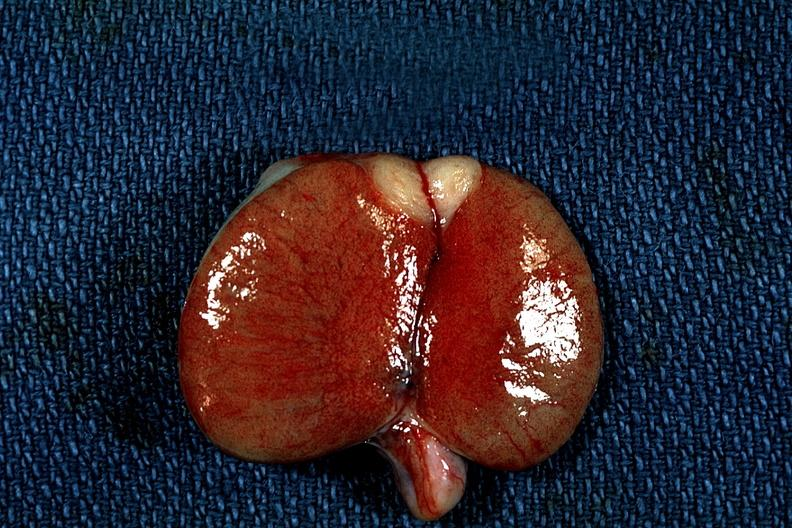does this image show discrete tumor mass?
Answer the question using a single word or phrase. Yes 